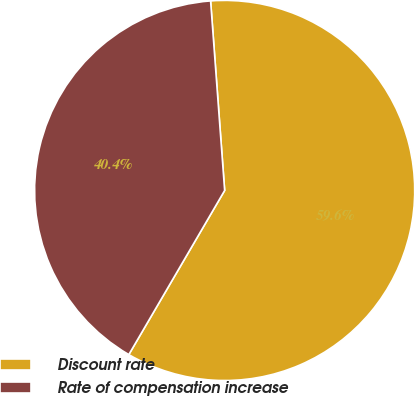Convert chart. <chart><loc_0><loc_0><loc_500><loc_500><pie_chart><fcel>Discount rate<fcel>Rate of compensation increase<nl><fcel>59.59%<fcel>40.41%<nl></chart> 